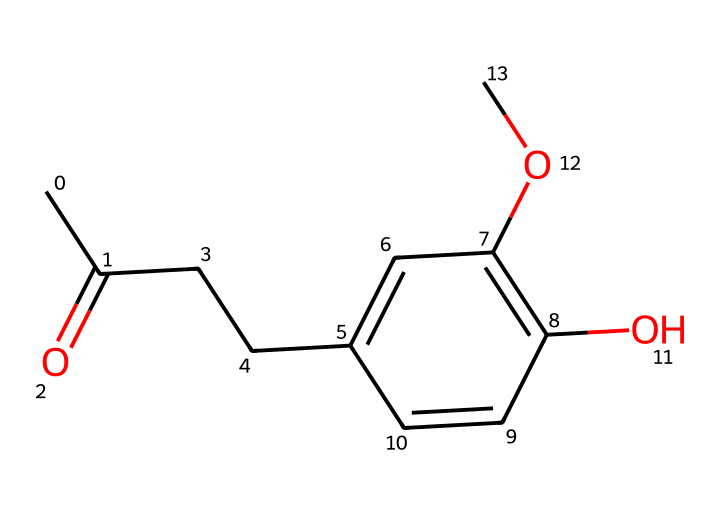What is the main functional group in raspberry ketone? The structure shows a carbonyl group (C=O) attached to a carbon chain, which identifies it as a ketone, the predominant functional group.
Answer: carbonyl group How many carbon atoms are present in raspberry ketone? By counting the carbon atoms in the structural representation, there are a total of 11 carbon atoms identified.
Answer: 11 How many oxygen atoms are present in raspberry ketone? The structure contains two oxygen atoms, one in the carbonyl group and another in the methoxy group (-O-CH3).
Answer: 2 What type of compound is raspberry ketone? Given its structure includes a carbonyl (ketone) and multiple carbon compounds, it is classified specifically as a ketone.
Answer: ketone Does raspberry ketone possess any hydroxyl groups? Yes, examining the structure reveals the presence of a hydroxyl group (-OH) attached to one of the benzene carbons.
Answer: yes What effect does the carbonyl group have on the reactivity of raspberry ketone? The carbonyl group increases reactivity due to its polar nature, making it susceptible to nucleophilic addition reactions.
Answer: increases reactivity Is raspberry ketone found naturally or synthetically? Raspberry ketone can be found naturally in raspberries and is often synthesized for commercial use in flavoring and fragrances.
Answer: naturally 